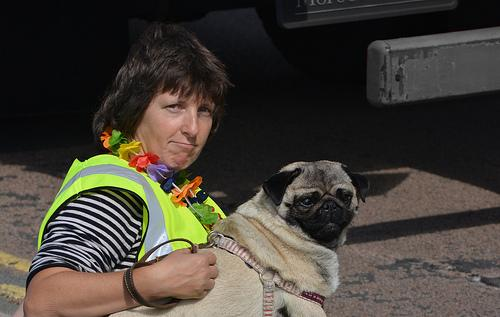Briefly describe the woman and her dog's expressions. Both the woman, with blue eyes and dark brown hair, and her light brown pug with black ears, are looking straight at the camera, seemingly calm and attentive. Provide a description of the woman's physical features in the image. The woman has dark brown hair, blue eyes, and is wearing a necklace with several color flowers, a black and white striped shirt, and a bright yellow vest. Mention the items the woman and her dog are wearing and indicate the relationship between the two. A woman in yellow vest, striped shirt, and colorful lei holds her brown pug with black ears on a leash, demonstrating a relationship of companionship and care. Describe the woman and her dog's attire using three distinct features. A woman in a yellow vest and floral lei sits with her pug, who wears a red and white harness, and both are secured by a brown-yellow leash. List the colors and garments the woman and the dog are wearing. The woman wears a black and white striped shirt, yellow safety vest, and flowered lei while the pug sports a red and white harness. What accessories does the woman wear and what is she holding? The woman wears a flowered lei around her neck, a yellow safety vest and holds a brown yellow leash connected to her dog's red and white harness. Mention the woman's attire and how she is interacting with the dog. The woman, wearing a black and white striped shirt, yellow safety vest, and flowered lei, sits with her brown pug dog on a leash, both looking at the camera. Explain the connection between the woman and the dog in the image. The woman, dressed in a striped shirt and yellow vest, shares a moment with her light brown pug, holding onto its leash while the dog wears a harness and looks at the camera. Write a brief description of what can be observed in the image. A woman in a yellow safety vest and a flowered lei is holding her brown pug dog with black ears, who is wearing a red and white harness, on a leash. Describe the appearance of the dog and how it is positioned in the image. The light brown pug has black ears and snout, and is wearing a red and white harness, looking at the camera while being held on a leash by the woman. What text can be found in the image? There is no visible text in the image. Ground the expression "flowered lei around her neck." X:96 Y:120 Width:128 Height:128 Is the necklace around the woman's neck made of diamonds? This question is misleading because the necklace is described as having several color flowers, and there's no mention of diamonds. Is the woman wearing a blue and white striped shirt? This question is misleading because the woman is wearing a black and white striped shirt, not a blue and white striped one. Does the woman have a short hairstyle in the image? This question creates confusion as the story mentions the woman has dark brown hair but not the length of her hair, inducing unnecessary doubt about the hairstyle. Which of these describes the dog: (a) tall and skinny, (b) short and plump, (c) average size? (b) short and plump State the color of the woman's eyes. Blue How does the image overall quality look? The image has good quality with clear details. Is there anything unusual in this image? No, the image presents a typical scene of a woman with her dog. Determine the dominant color of the woman's shirt. Black and white stripes. Is the woman holding a cat instead of a dog? The question is misleading as the story mentions a small dog on leash, a pug, held by the woman, and not a cat. List the color attributes of the dog. Light brown, black ears, black snout. What is the woman wearing around her neck? A necklace with several color flowers. Describe the main subjects in the photo. A woman wearing a yellow vest and holding a brown pug with black ears. What type of harness is the dog wearing? Red and white harness. Assess the lighting conditions in the image. The lighting is balanced with some dark shadows on the pavement. What interactions exist between the woman and the dog? The woman is holding the dog's leash and sitting with her dog. Does the woman have blue eyes in the image? The instructions only mention the woman's right and left eye but not their color. Asking if her eyes are blue is misleading since there's no information about her eye color. Identify the objects in the image. Woman, brown pug, yellow vest, striped shirt, flower necklace, dog leash, pavement. Is the pug wearing a green harness in the image? It is misleading because the pug is wearing a red and white harness, not a green one as the question suggests. Point out the positions of the woman's eyes in the image. Right eye: X:162 Y:100 Width:21 Height:21, Left eye: X:195 Y:101 Width:17 Height:17 Determine the location of the dog's nose. X:318 Y:197 Width:20 Height:20 What type of animal is the main focus of the image? A brown pug. What sentiment does this image convey? A positive sentiment, with a woman enjoying time with her dog. 